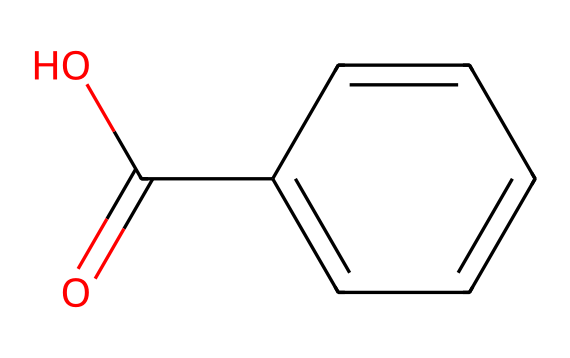what is the main functional group in this compound? The compound contains a carboxylic acid functional group as indicated by the -COOH part of the structure, which is a common functional group represented in the structure.
Answer: carboxylic acid how many carbon atoms are present in this compound? By counting the carbon atoms in the aromatic ring and the carboxylic acid, we find a total of 7 carbon atoms in the structure (6 from the ring + 1 from the -COOH group).
Answer: 7 is this compound aromatic? The presence of a benzene ring indicates that the compound has delocalized π electrons, which makes it aromatic.
Answer: yes what property does the carboxylic acid group impart to this compound? The carboxylic acid group contributes acidity to the compound, allowing it to donate a proton (H+), thus exhibiting acidic properties.
Answer: acidity can this compound be used in livestock remedies? The presence of the carboxylic acid group and aromatic ring suggests it may possess antimicrobial and antioxidant properties, which can be beneficial in livestock health.
Answer: yes what type of bonds are primarily present in the aromatic ring of this compound? The aromatic ring contains alternating single and double bonds, known as resonance, which is characteristic of aromatic compounds, allowing for stability in the structure.
Answer: resonance what might be a potential application of this compound in traditional herbal remedies for livestock? Given its properties, it could potentially be used for treating infections or as an anti-inflammatory due to the effects of the carboxylic acid group and its aromatic nature.
Answer: treating infections 